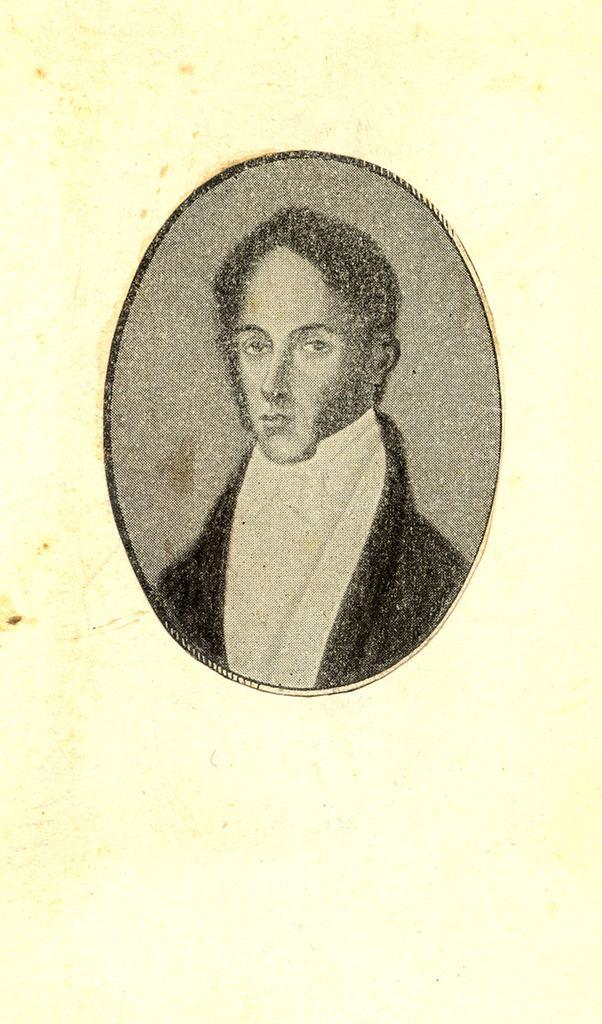In one or two sentences, can you explain what this image depicts? In this picture I can see there is a painting of a man in a book and he is wearing a black coat and a white shirt. 